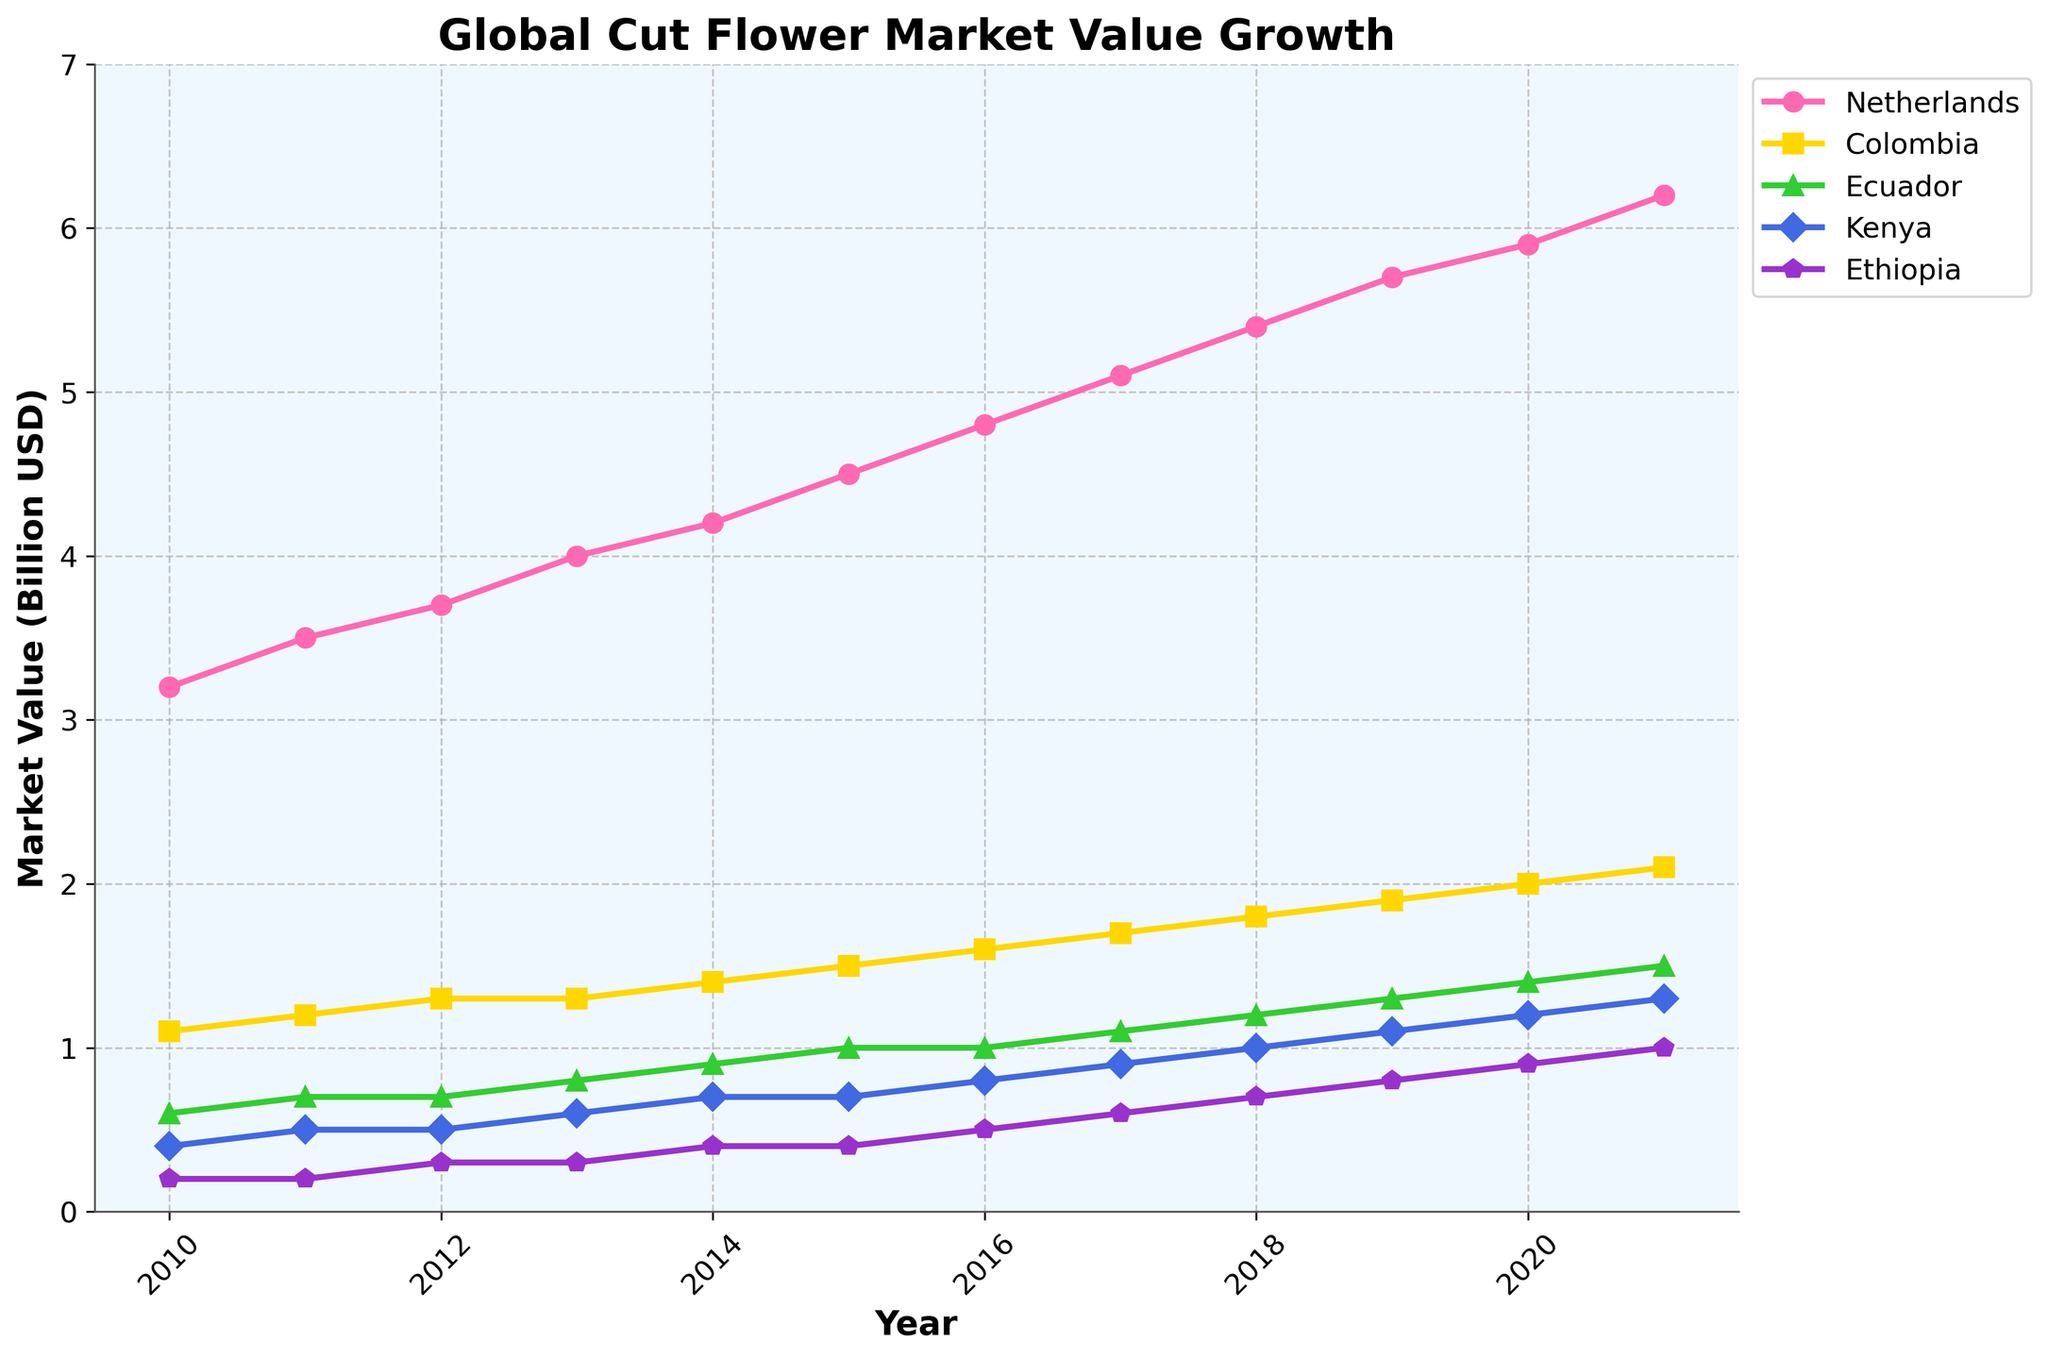Which country showed the highest market value growth from 2010 to 2021? To determine this, I need to look at each country's value in 2010 and compare it with its value in 2021. The Netherlands started at 3.2 billion USD in 2010 and reached 6.2 billion USD by 2021. This is the largest absolute growth among all countries.
Answer: Netherlands Which years did the Ethiopian market value equal or surpass 1.0 billion USD? Checking the values for Ethiopia, it starts at 0.2 billion USD in 2010 and reaches 1.0 billion USD by 2021. The market value equals 1.0 billion USD in 2021.
Answer: 2021 How many times higher was the Netherlands' market value in 2021 compared to Kenya's in 2011? In 2021, the Netherlands had a market value of 6.2 billion USD, while Kenya had 0.5 billion USD in 2011. So, 6.2 / 0.5 = 12.4 times higher.
Answer: 12.4 times Which country had the most consistent (smoothest) growth in market value over the years? Observing the trend lines, both the Netherlands and Colombia show fairly smooth upward trends. However, the Netherlands has a consistent linear increase, making it the most consistent.
Answer: Netherlands In which year did Kenya's market value surpass Ecuador's? Comparing the market values year by year, in 2017, Kenya's value is 0.9 billion USD, while Ecuador's is 1.1 billion USD. In 2018, Kenya's value is 1.0 billion USD, which is equal to Ecuador's. By 2019, Kenya surpasses Ecuador (1.1 vs 1.3).
Answer: 2019 What is the range of Colombia’s market value during the period 2010-2021? The range is the difference between the highest and lowest values. Colombia's value in 2010 is 1.1 billion USD and in 2021 is 2.1 billion USD. The range is 2.1 - 1.1 = 1.0 billion USD.
Answer: 1.0 billion USD Which country had the greatest increase in market value between 2015 and 2020? Netherlands increased from 4.5 to 5.9 (1.4), Colombia from 1.5 to 2.0 (0.5), Ecuador from 1.0 to 1.4 (0.4), Kenya from 0.7 to 1.2 (0.5), Ethiopia from 0.4 to 0.9 (0.5). The Netherlands shows the greatest increase.
Answer: Netherlands What is the average market value of Ethiopia over the depicted years? Summing up the market values: 0.2 + 0.2 + 0.3 + 0.3 + 0.4 + 0.4 + 0.5 + 0.6 + 0.7 + 0.8 + 0.9 + 1.0 = 5.3. The average value is 5.3 / 12 ≈ 0.442 billion USD.
Answer: 0.442 billion USD Did any country show a decline in market value during the studied period? Examining the lines, all the presented countries only show an increase or a steady market value, but not a decline.
Answer: no 